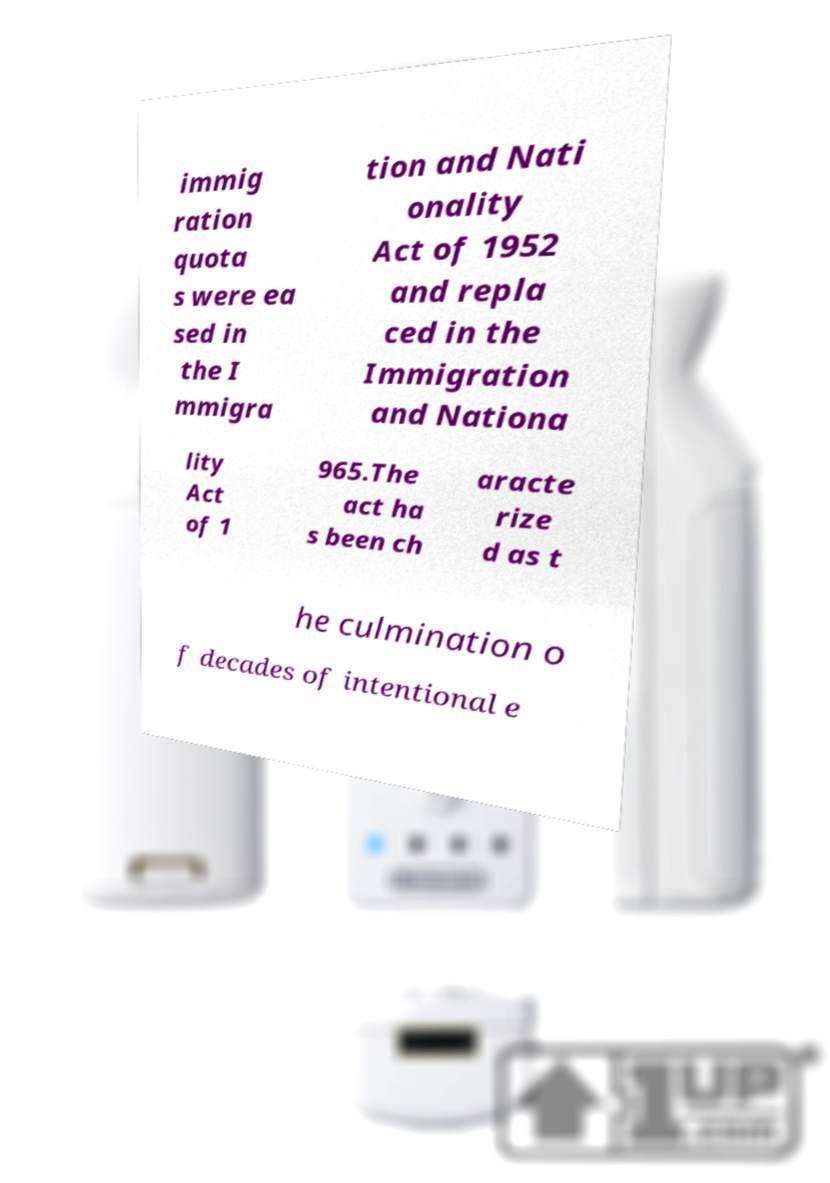What messages or text are displayed in this image? I need them in a readable, typed format. immig ration quota s were ea sed in the I mmigra tion and Nati onality Act of 1952 and repla ced in the Immigration and Nationa lity Act of 1 965.The act ha s been ch aracte rize d as t he culmination o f decades of intentional e 